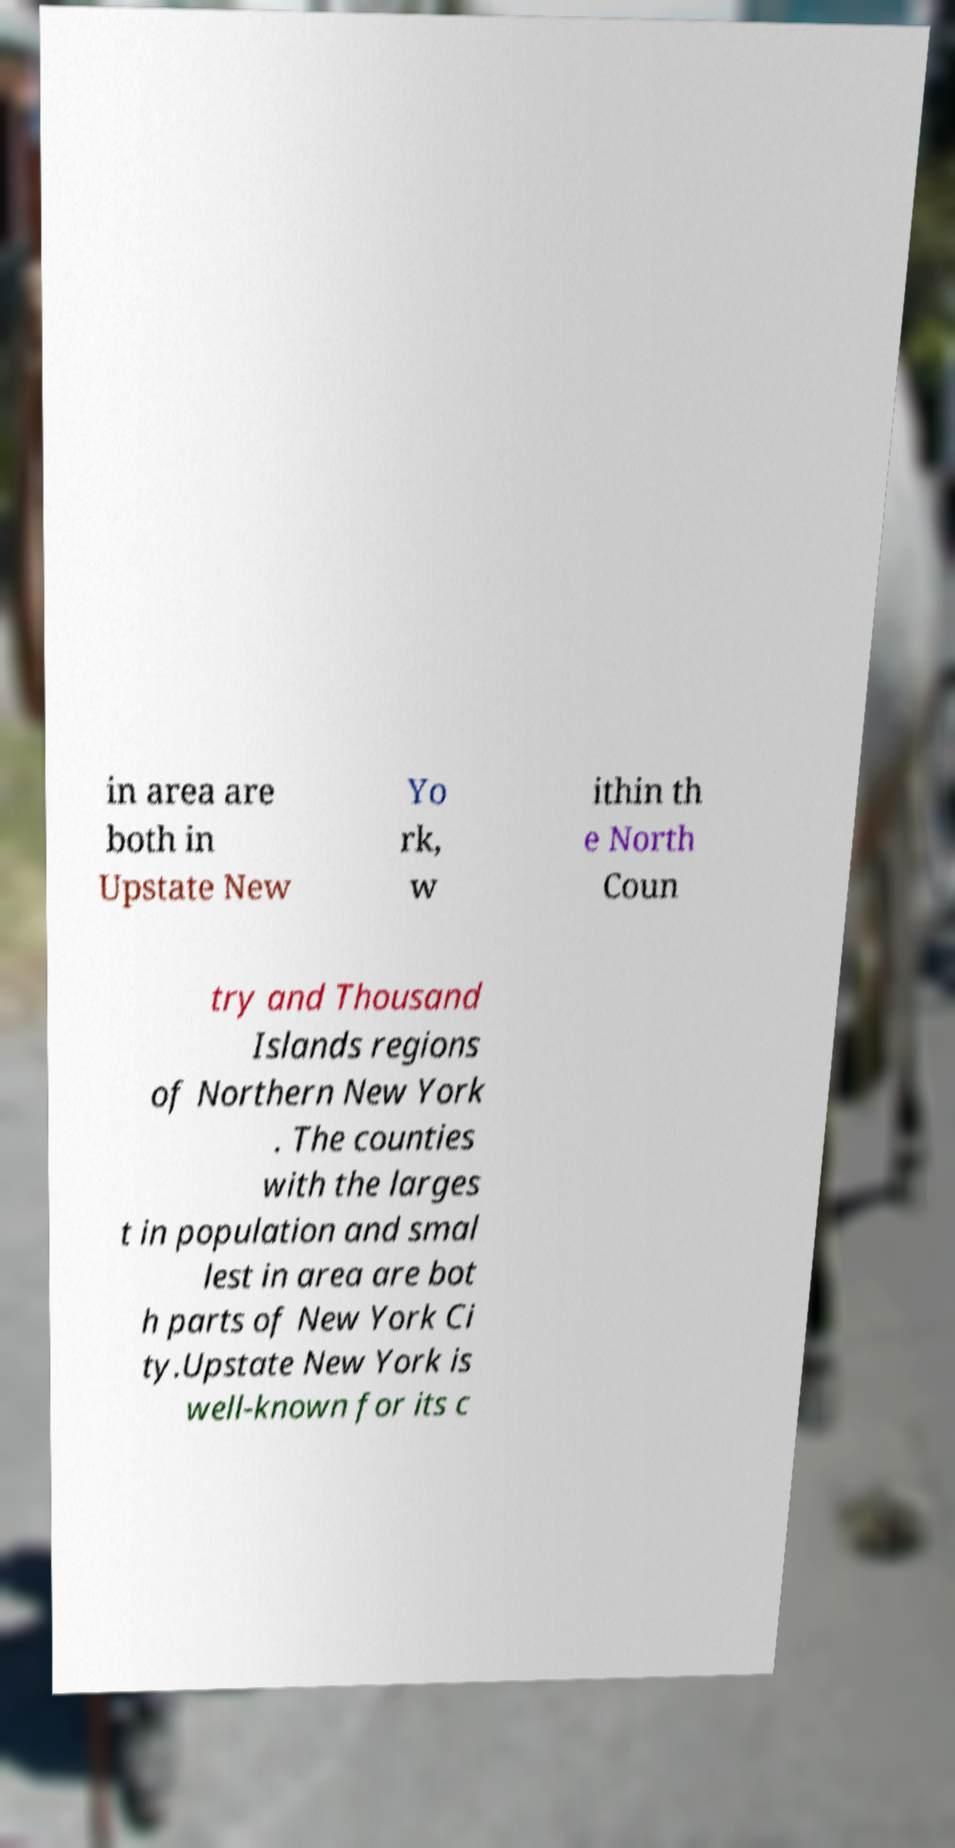Can you accurately transcribe the text from the provided image for me? in area are both in Upstate New Yo rk, w ithin th e North Coun try and Thousand Islands regions of Northern New York . The counties with the larges t in population and smal lest in area are bot h parts of New York Ci ty.Upstate New York is well-known for its c 